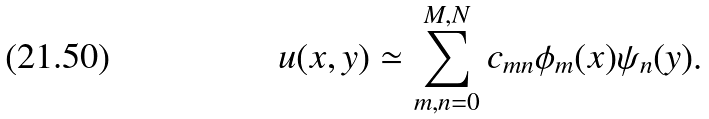<formula> <loc_0><loc_0><loc_500><loc_500>u ( x , y ) \simeq \sum _ { m , n = 0 } ^ { M , N } c _ { m n } \phi _ { m } ( x ) \psi _ { n } ( y ) .</formula> 